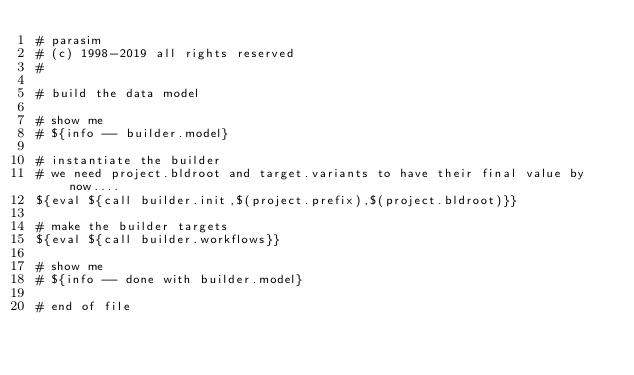Convert code to text. <code><loc_0><loc_0><loc_500><loc_500><_ObjectiveC_># parasim
# (c) 1998-2019 all rights reserved
#

# build the data model

# show me
# ${info -- builder.model}

# instantiate the builder
# we need project.bldroot and target.variants to have their final value by now....
${eval ${call builder.init,$(project.prefix),$(project.bldroot)}}

# make the builder targets
${eval ${call builder.workflows}}

# show me
# ${info -- done with builder.model}

# end of file
</code> 